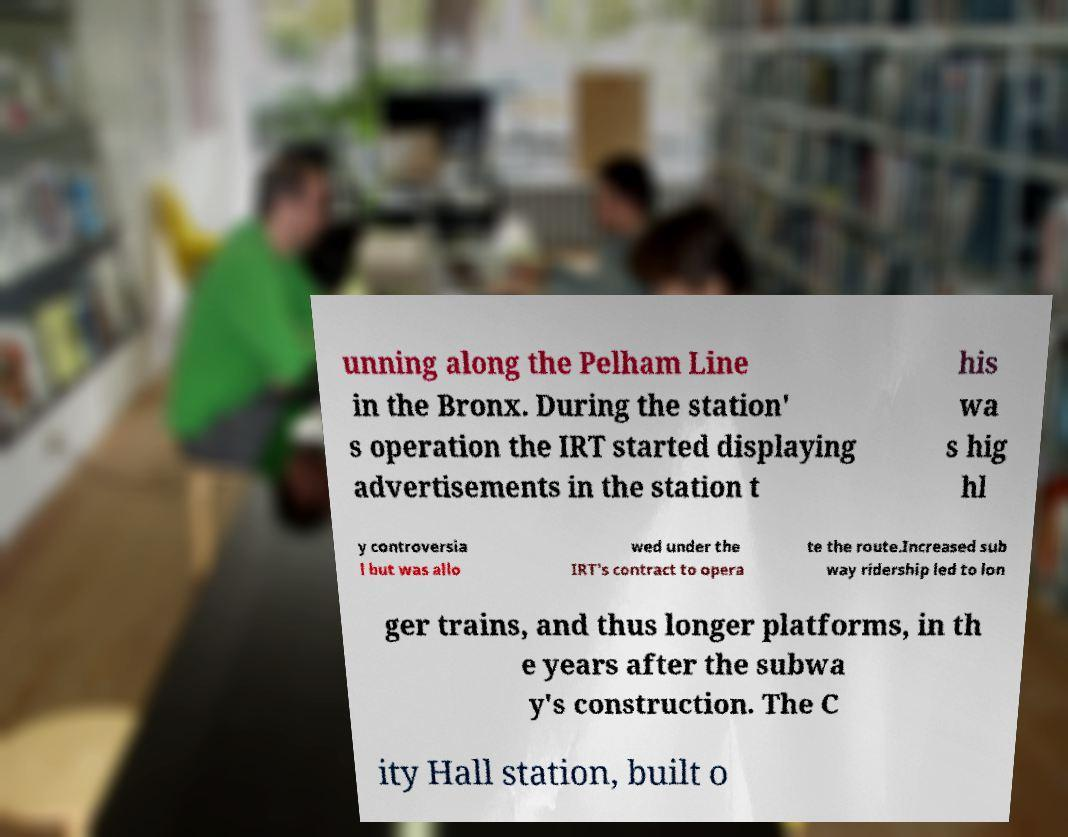What messages or text are displayed in this image? I need them in a readable, typed format. unning along the Pelham Line in the Bronx. During the station' s operation the IRT started displaying advertisements in the station t his wa s hig hl y controversia l but was allo wed under the IRT's contract to opera te the route.Increased sub way ridership led to lon ger trains, and thus longer platforms, in th e years after the subwa y's construction. The C ity Hall station, built o 